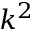<formula> <loc_0><loc_0><loc_500><loc_500>k ^ { 2 }</formula> 